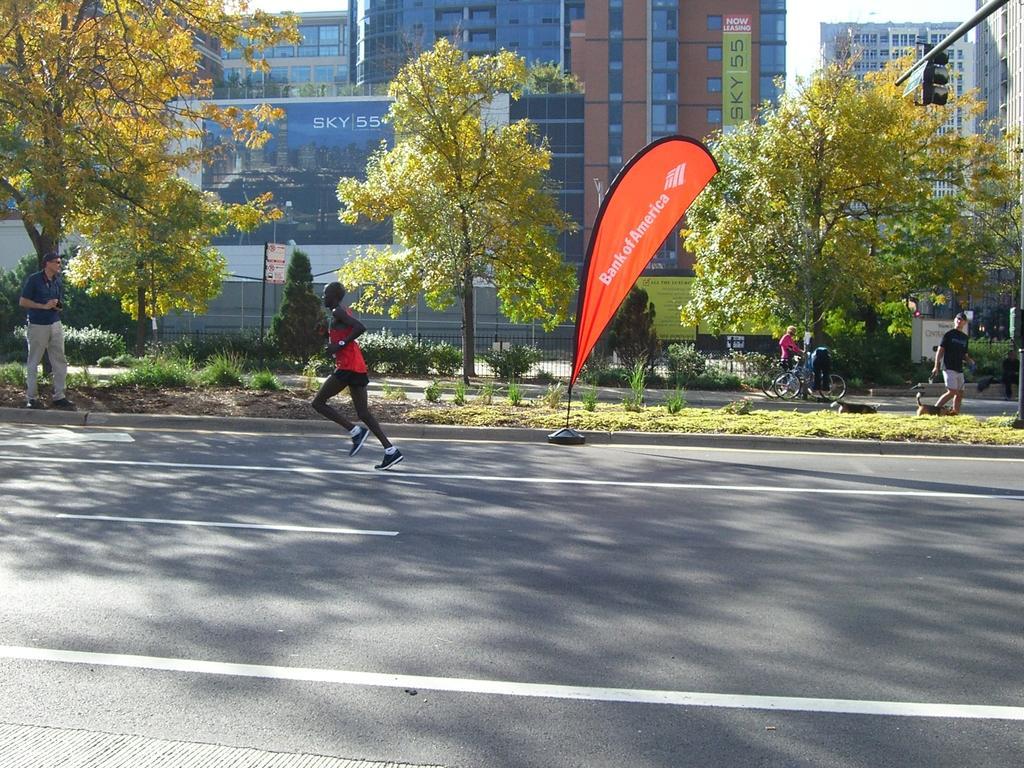Please provide a concise description of this image. This is an outside view. Here I can see a person running on the road towards the left side. On the left side there is a man holding a camera in the hand and standing beside the road facing towards the right side. On the right side there is another man walking by holding the belt of a dog. In the background there are two persons standing on the road by holding the bicycles. Beside the road, I can see the a flag, grass and plants. In the background there are many trees and buildings. In the top right-hand corner there is a traffic signal pole. 